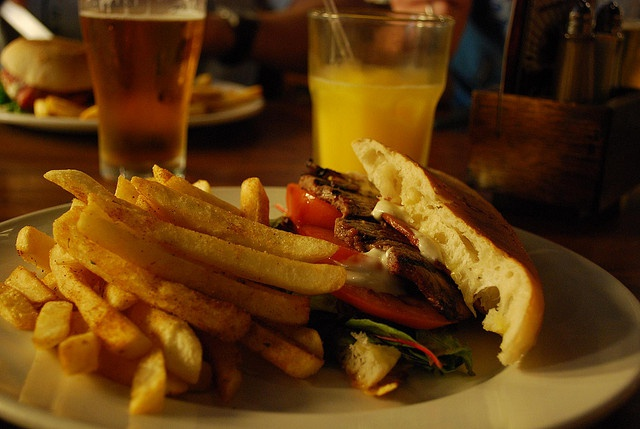Describe the objects in this image and their specific colors. I can see sandwich in black, maroon, olive, and tan tones, cup in black, olive, maroon, and orange tones, cup in black, maroon, and olive tones, sandwich in black, maroon, and olive tones, and spoon in black, maroon, olive, and tan tones in this image. 